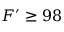Convert formula to latex. <formula><loc_0><loc_0><loc_500><loc_500>F ^ { \prime } \geq 9 8 \</formula> 